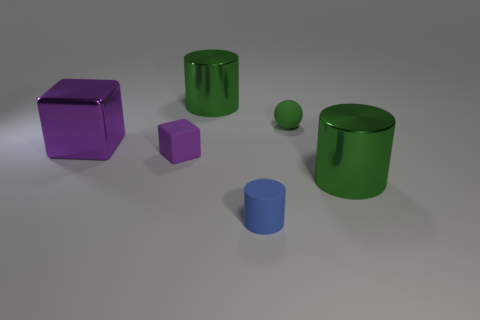Add 3 small things. How many objects exist? 9 Subtract all balls. How many objects are left? 5 Subtract 0 gray balls. How many objects are left? 6 Subtract all green balls. Subtract all cylinders. How many objects are left? 2 Add 6 tiny cylinders. How many tiny cylinders are left? 7 Add 1 gray rubber spheres. How many gray rubber spheres exist? 1 